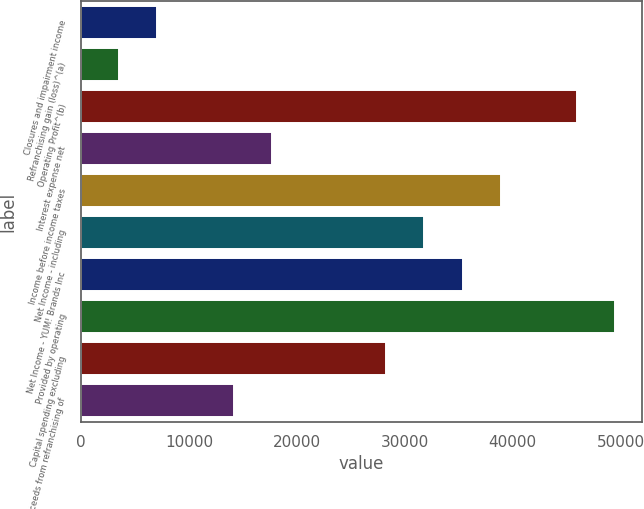Convert chart. <chart><loc_0><loc_0><loc_500><loc_500><bar_chart><fcel>Closures and impairment income<fcel>Refranchising gain (loss)^(a)<fcel>Operating Profit^(b)<fcel>Interest expense net<fcel>Income before income taxes<fcel>Net Income - including<fcel>Net Income - YUM! Brands Inc<fcel>Provided by operating<fcel>Capital spending excluding<fcel>Proceeds from refranchising of<nl><fcel>7069.36<fcel>3534.91<fcel>45948.4<fcel>17672.7<fcel>38879.5<fcel>31810.6<fcel>35345<fcel>49482.9<fcel>28276.1<fcel>14138.3<nl></chart> 